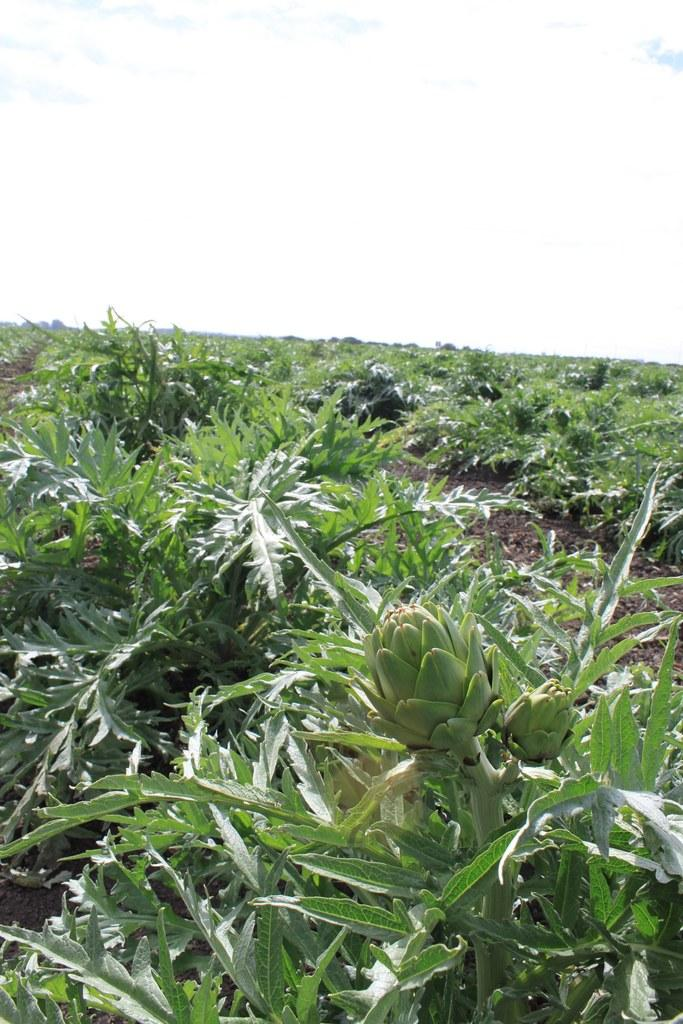What type of living organisms can be seen in the image? Plants can be seen in the image. What type of credit can be seen on the tail of the plant in the image? There is no credit or tail present on the plant in the image. 